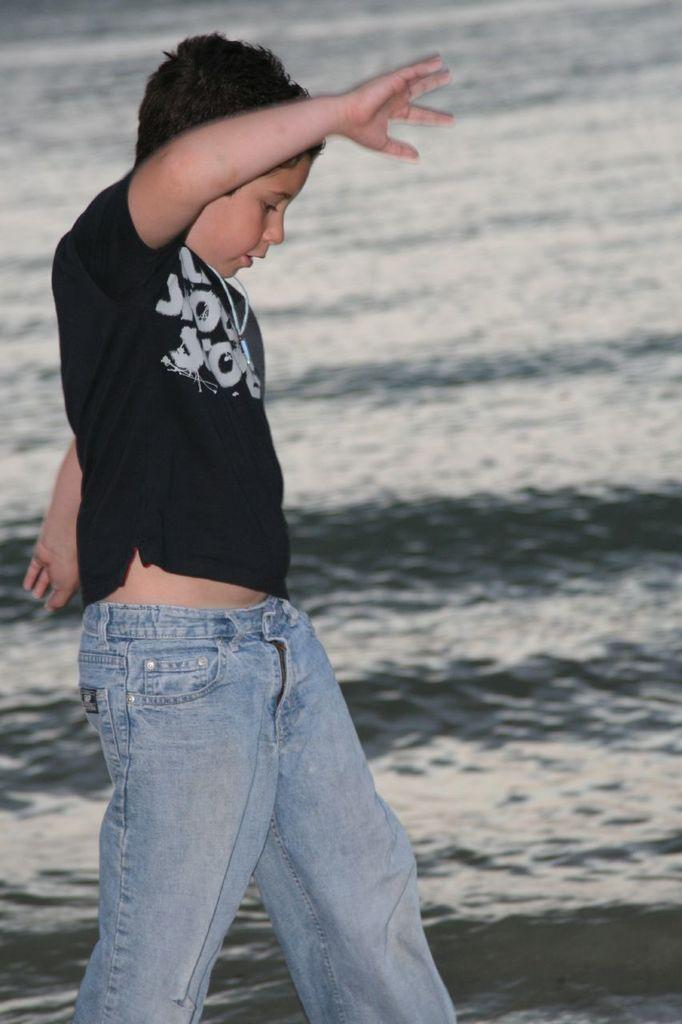Who is the main subject in the image? There is a boy in the image. What is the boy wearing? The boy is wearing a black t-shirt and blue jeans. What is the boy's posture in the image? The boy is standing. What can be seen in the background of the image? There is water visible in the background of the image. What type of respect does the tiger show towards the boy in the image? There is no tiger present in the image, so it is not possible to determine any interaction or respect between the boy and a tiger. 